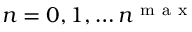<formula> <loc_0><loc_0><loc_500><loc_500>n = 0 , 1 , \dots n ^ { m a x }</formula> 